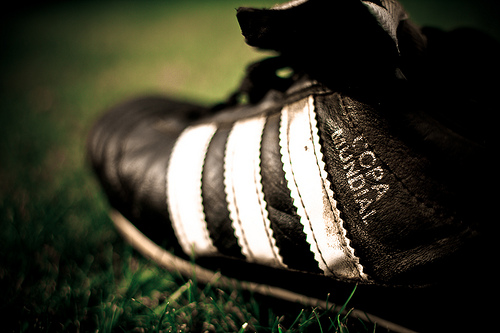<image>
Can you confirm if the grass is under the shoe? Yes. The grass is positioned underneath the shoe, with the shoe above it in the vertical space. 